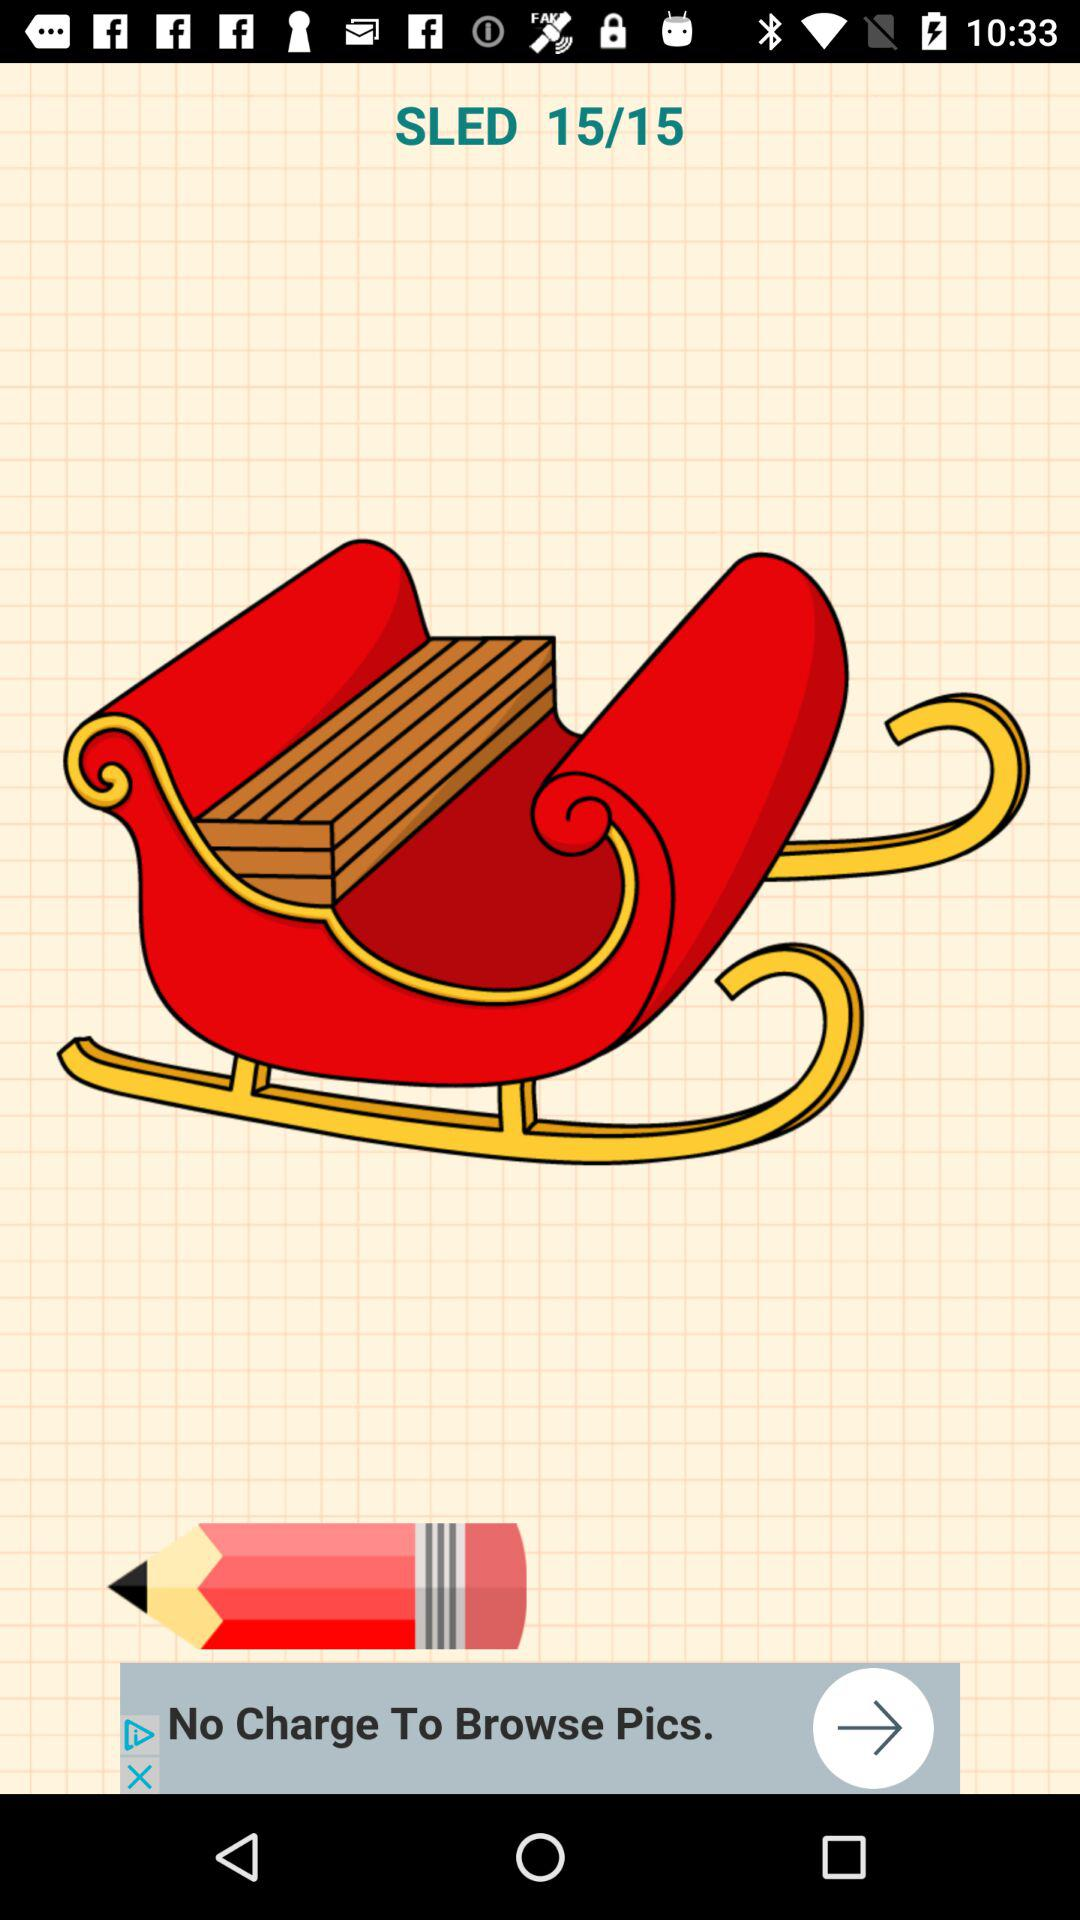What is the total number of images? The total number of images is 15. 